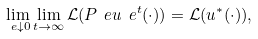Convert formula to latex. <formula><loc_0><loc_0><loc_500><loc_500>\lim _ { \ e \downarrow 0 } \lim _ { t \rightarrow \infty } \mathcal { L } ( P _ { \ } e u _ { \ } e ^ { t } ( \cdot ) ) = \mathcal { L } ( u ^ { * } ( \cdot ) ) ,</formula> 